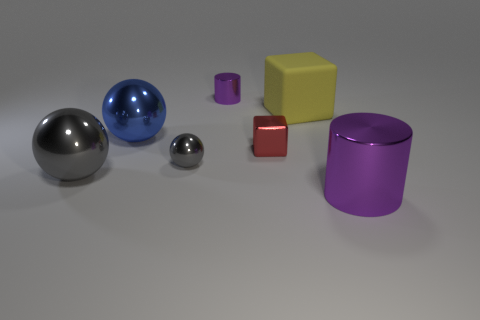Subtract all gray shiny balls. How many balls are left? 1 Subtract all yellow cylinders. How many gray balls are left? 2 Add 3 tiny blue blocks. How many objects exist? 10 Subtract all spheres. How many objects are left? 4 Subtract all cyan balls. Subtract all yellow cylinders. How many balls are left? 3 Add 3 big gray metal things. How many big gray metal things exist? 4 Subtract 0 brown spheres. How many objects are left? 7 Subtract all yellow metal cubes. Subtract all tiny gray spheres. How many objects are left? 6 Add 5 metallic spheres. How many metallic spheres are left? 8 